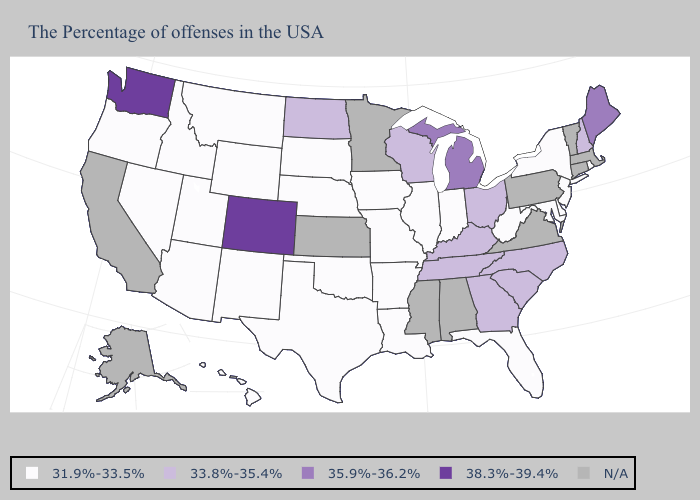Name the states that have a value in the range 33.8%-35.4%?
Concise answer only. New Hampshire, North Carolina, South Carolina, Ohio, Georgia, Kentucky, Tennessee, Wisconsin, North Dakota. What is the lowest value in the USA?
Answer briefly. 31.9%-33.5%. Which states hav the highest value in the Northeast?
Be succinct. Maine. What is the value of Florida?
Concise answer only. 31.9%-33.5%. What is the lowest value in the USA?
Short answer required. 31.9%-33.5%. Name the states that have a value in the range 38.3%-39.4%?
Concise answer only. Colorado, Washington. What is the value of North Dakota?
Write a very short answer. 33.8%-35.4%. Name the states that have a value in the range 38.3%-39.4%?
Answer briefly. Colorado, Washington. Among the states that border Vermont , which have the lowest value?
Be succinct. New York. What is the lowest value in states that border Wyoming?
Write a very short answer. 31.9%-33.5%. What is the value of Massachusetts?
Be succinct. N/A. What is the highest value in the USA?
Short answer required. 38.3%-39.4%. Does Wyoming have the highest value in the West?
Short answer required. No. Name the states that have a value in the range 38.3%-39.4%?
Short answer required. Colorado, Washington. 